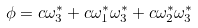Convert formula to latex. <formula><loc_0><loc_0><loc_500><loc_500>\phi = c \omega _ { 3 } ^ { * } + c \omega _ { 1 } ^ { * } \omega _ { 3 } ^ { * } + c \omega _ { 2 } ^ { * } \omega _ { 3 } ^ { * }</formula> 